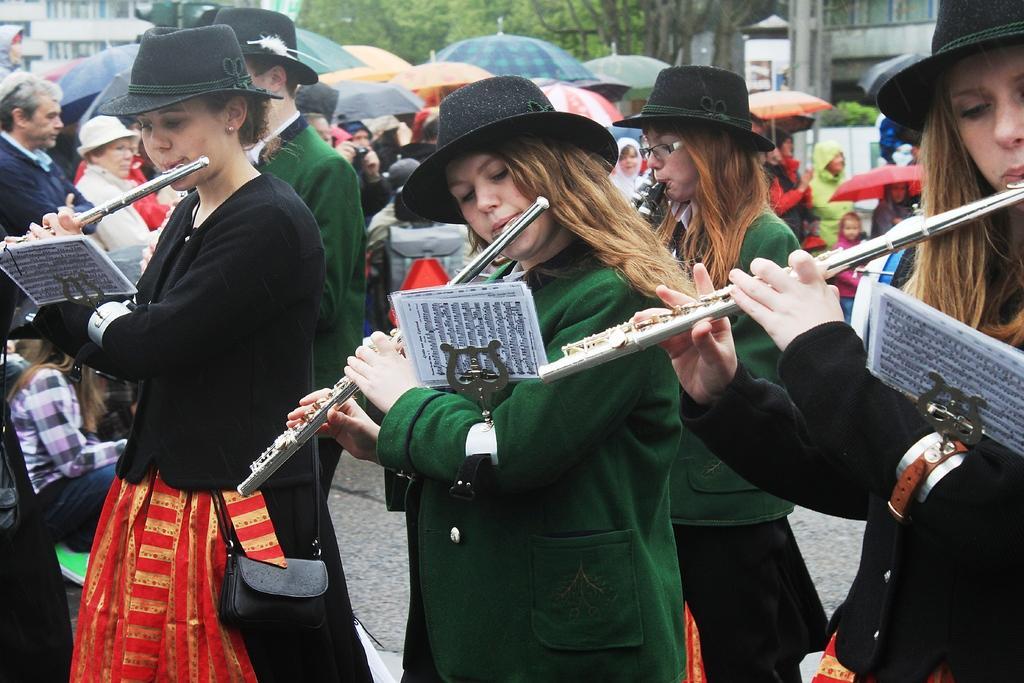How would you summarize this image in a sentence or two? 3 beautiful girls are playing the flutes in the middle a girl is wearing a green color dress on the left a black color dress and behind them there are umbrellas. 